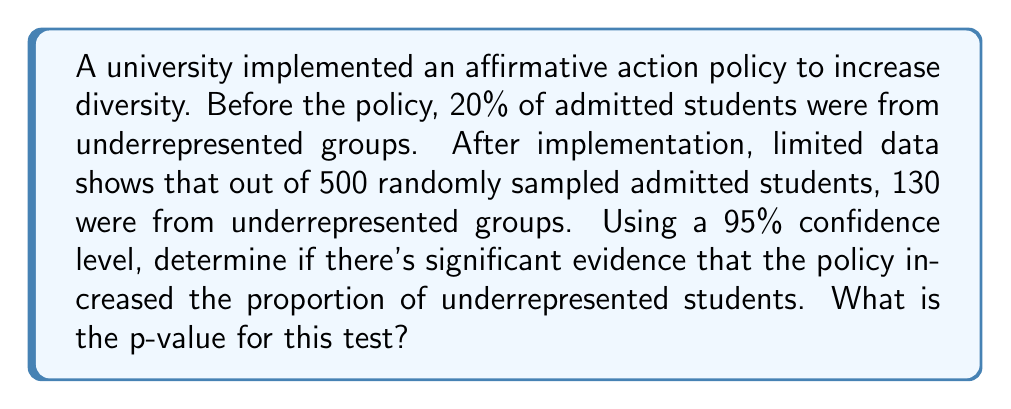Can you solve this math problem? To solve this inverse problem and infer the impact of the affirmative action policy, we'll use a hypothesis test for a population proportion.

Step 1: Define the hypotheses
$H_0: p = 0.20$ (null hypothesis: proportion remains unchanged)
$H_a: p > 0.20$ (alternative hypothesis: proportion has increased)

Step 2: Calculate the sample proportion
$\hat{p} = \frac{130}{500} = 0.26$

Step 3: Calculate the test statistic (z-score)
$$z = \frac{\hat{p} - p_0}{\sqrt{\frac{p_0(1-p_0)}{n}}}$$
where $p_0 = 0.20$, $n = 500$

$$z = \frac{0.26 - 0.20}{\sqrt{\frac{0.20(1-0.20)}{500}}} = \frac{0.06}{\sqrt{0.00032}} = \frac{0.06}{0.017889} = 3.3539$$

Step 4: Find the p-value
The p-value is the area to the right of the z-score in the standard normal distribution.

Using a z-table or calculator, we find:
$P(Z > 3.3539) = 1 - P(Z < 3.3539) = 1 - 0.9996 = 0.0004$

Step 5: Compare the p-value to the significance level
The p-value (0.0004) is less than the significance level (0.05), so we reject the null hypothesis.
Answer: 0.0004 